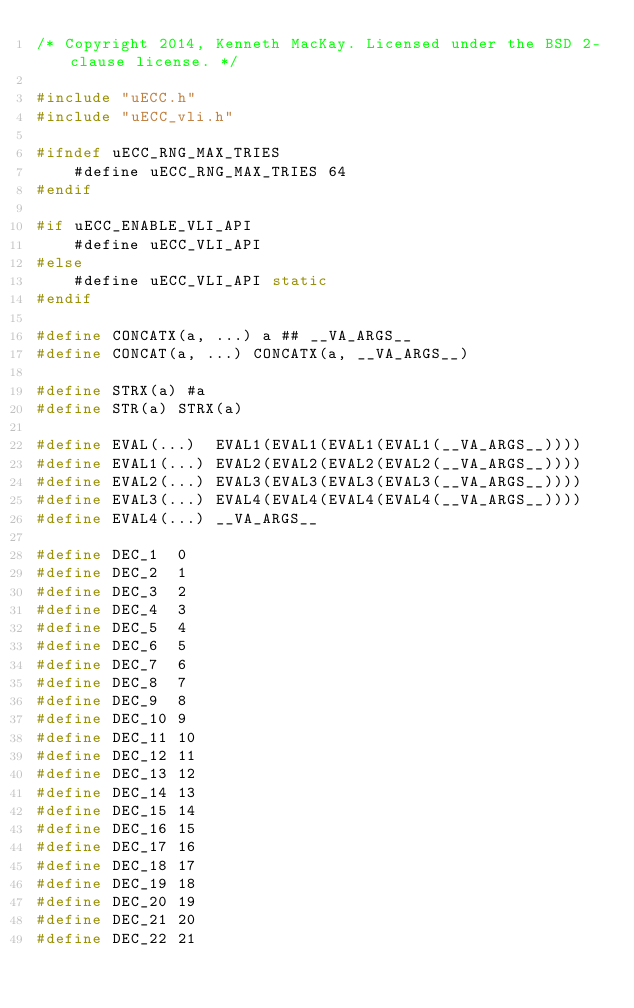Convert code to text. <code><loc_0><loc_0><loc_500><loc_500><_C_>/* Copyright 2014, Kenneth MacKay. Licensed under the BSD 2-clause license. */

#include "uECC.h"
#include "uECC_vli.h"

#ifndef uECC_RNG_MAX_TRIES
    #define uECC_RNG_MAX_TRIES 64
#endif

#if uECC_ENABLE_VLI_API
    #define uECC_VLI_API
#else
    #define uECC_VLI_API static
#endif

#define CONCATX(a, ...) a ## __VA_ARGS__
#define CONCAT(a, ...) CONCATX(a, __VA_ARGS__)

#define STRX(a) #a
#define STR(a) STRX(a)

#define EVAL(...)  EVAL1(EVAL1(EVAL1(EVAL1(__VA_ARGS__))))
#define EVAL1(...) EVAL2(EVAL2(EVAL2(EVAL2(__VA_ARGS__))))
#define EVAL2(...) EVAL3(EVAL3(EVAL3(EVAL3(__VA_ARGS__))))
#define EVAL3(...) EVAL4(EVAL4(EVAL4(EVAL4(__VA_ARGS__))))
#define EVAL4(...) __VA_ARGS__

#define DEC_1  0
#define DEC_2  1
#define DEC_3  2
#define DEC_4  3
#define DEC_5  4
#define DEC_6  5
#define DEC_7  6
#define DEC_8  7
#define DEC_9  8
#define DEC_10 9
#define DEC_11 10
#define DEC_12 11
#define DEC_13 12
#define DEC_14 13
#define DEC_15 14
#define DEC_16 15
#define DEC_17 16
#define DEC_18 17
#define DEC_19 18
#define DEC_20 19
#define DEC_21 20
#define DEC_22 21</code> 